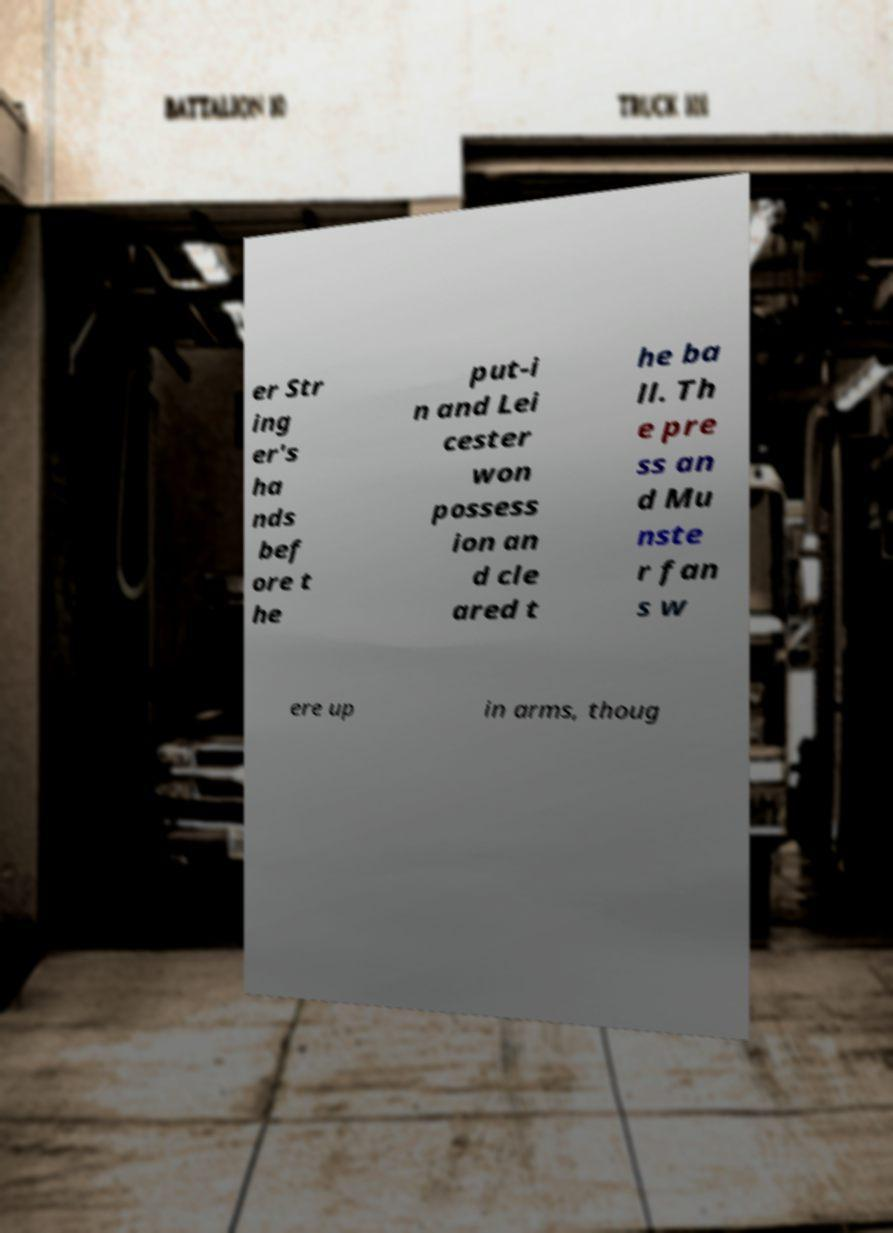For documentation purposes, I need the text within this image transcribed. Could you provide that? er Str ing er's ha nds bef ore t he put-i n and Lei cester won possess ion an d cle ared t he ba ll. Th e pre ss an d Mu nste r fan s w ere up in arms, thoug 